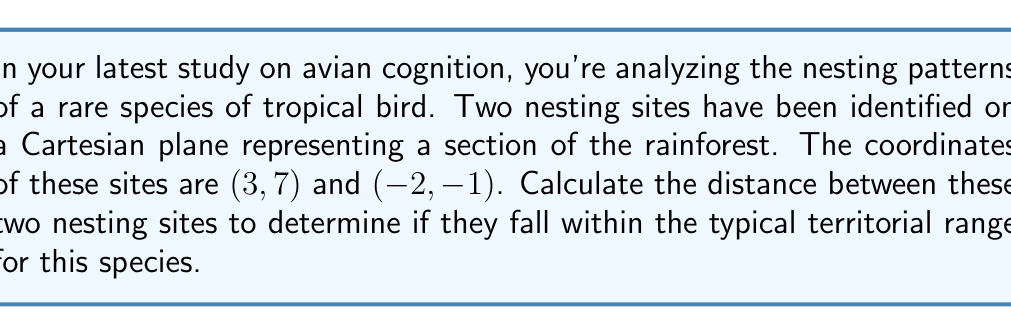Help me with this question. To calculate the distance between two points on a Cartesian plane, we use the distance formula, which is derived from the Pythagorean theorem:

$$d = \sqrt{(x_2 - x_1)^2 + (y_2 - y_1)^2}$$

Where $(x_1, y_1)$ and $(x_2, y_2)$ are the coordinates of the two points.

Let's assign our points:
Point 1 (first nesting site): $(x_1, y_1) = (3, 7)$
Point 2 (second nesting site): $(x_2, y_2) = (-2, -1)$

Now, let's substitute these values into the formula:

$$\begin{align*}
d &= \sqrt{(x_2 - x_1)^2 + (y_2 - y_1)^2} \\
&= \sqrt{(-2 - 3)^2 + (-1 - 7)^2} \\
&= \sqrt{(-5)^2 + (-8)^2} \\
&= \sqrt{25 + 64} \\
&= \sqrt{89}
\end{align*}$$

The distance between the two nesting sites is $\sqrt{89}$ units.

To simplify this further, we can approximate the square root:

$$\sqrt{89} \approx 9.43$$

Therefore, the distance between the two nesting sites is approximately 9.43 units.

[asy]
unitsize(1cm);
dot((3,7),red);
dot((-2,-1),red);
draw((3,7)--(-2,-1),blue);
label("(3, 7)", (3,7), NE);
label("(-2, -1)", (-2,-1), SW);
label("d", (0.5,3), NW);
axes(-3,-2,4,8,Arrow);
[/asy]
Answer: The distance between the two nesting sites is $\sqrt{89}$ units, or approximately 9.43 units. 